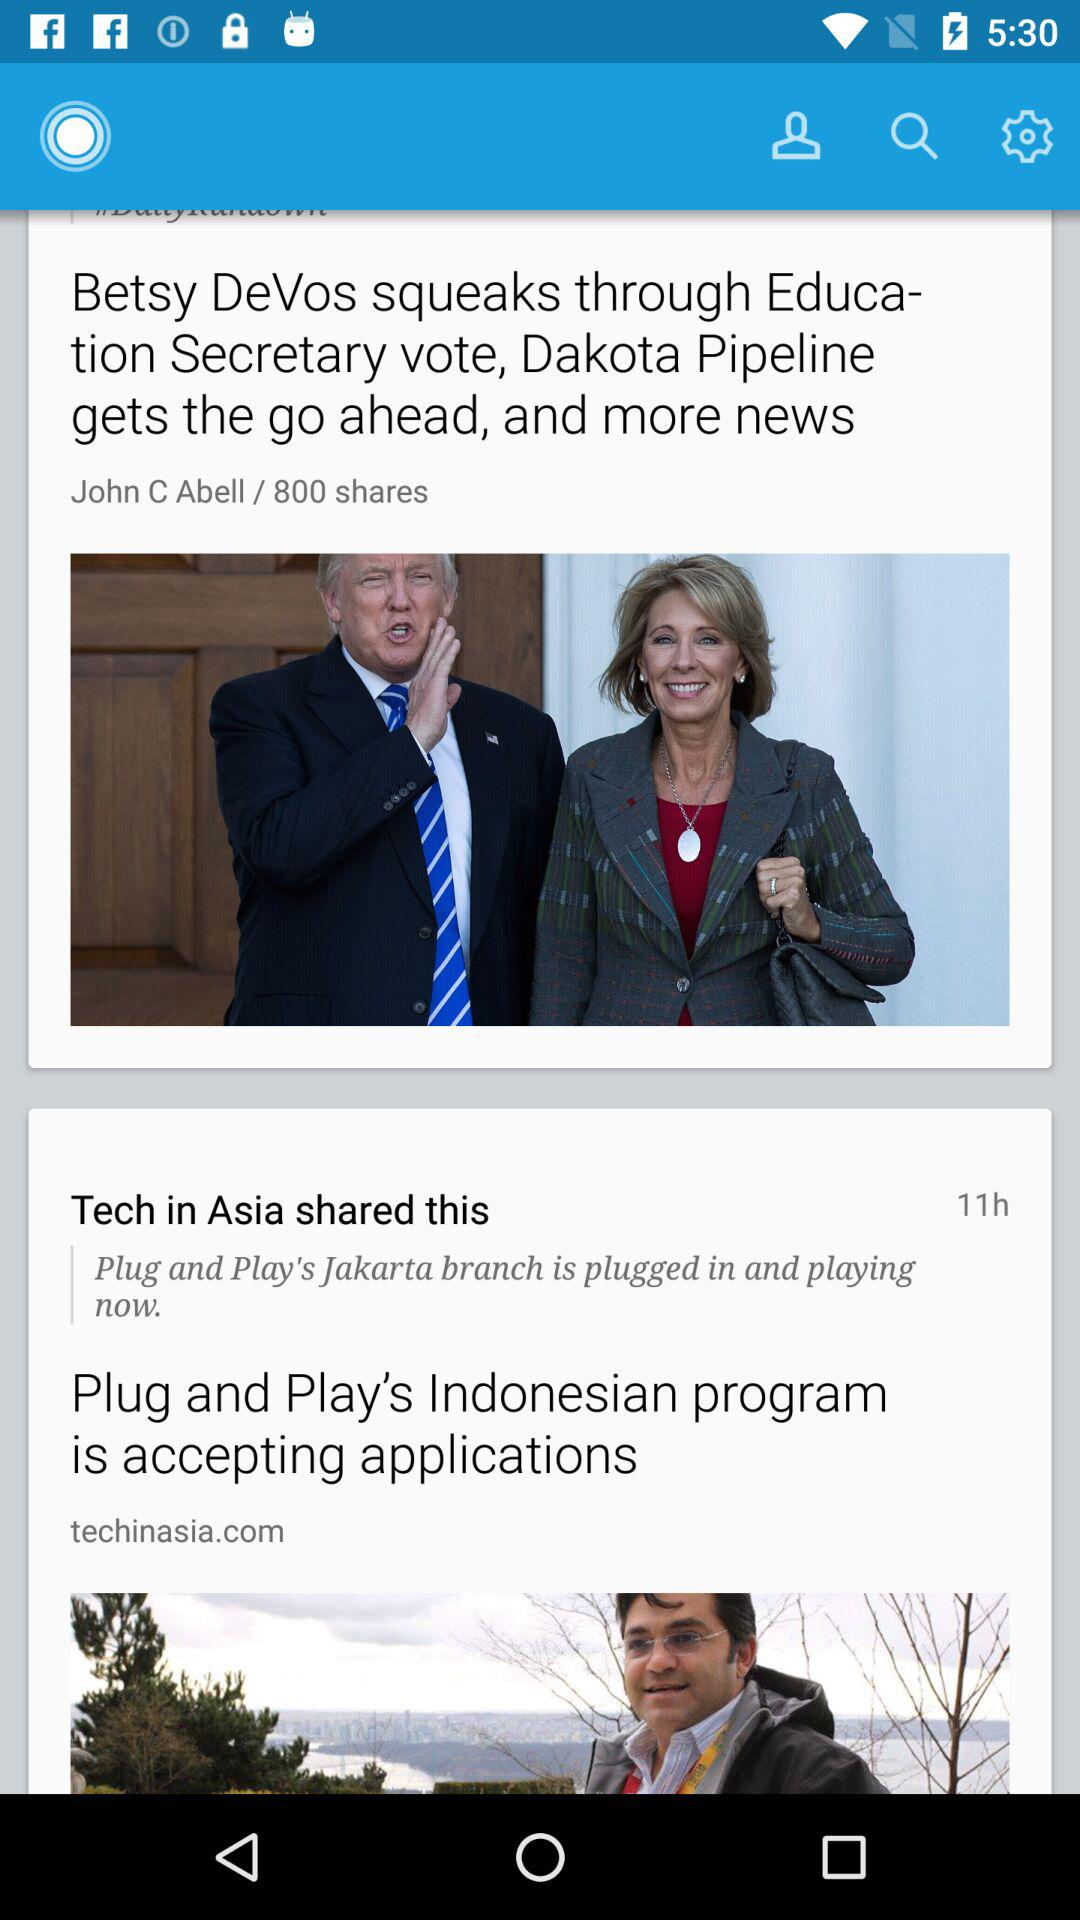How many more stories are there after the first one?
Answer the question using a single word or phrase. 1 